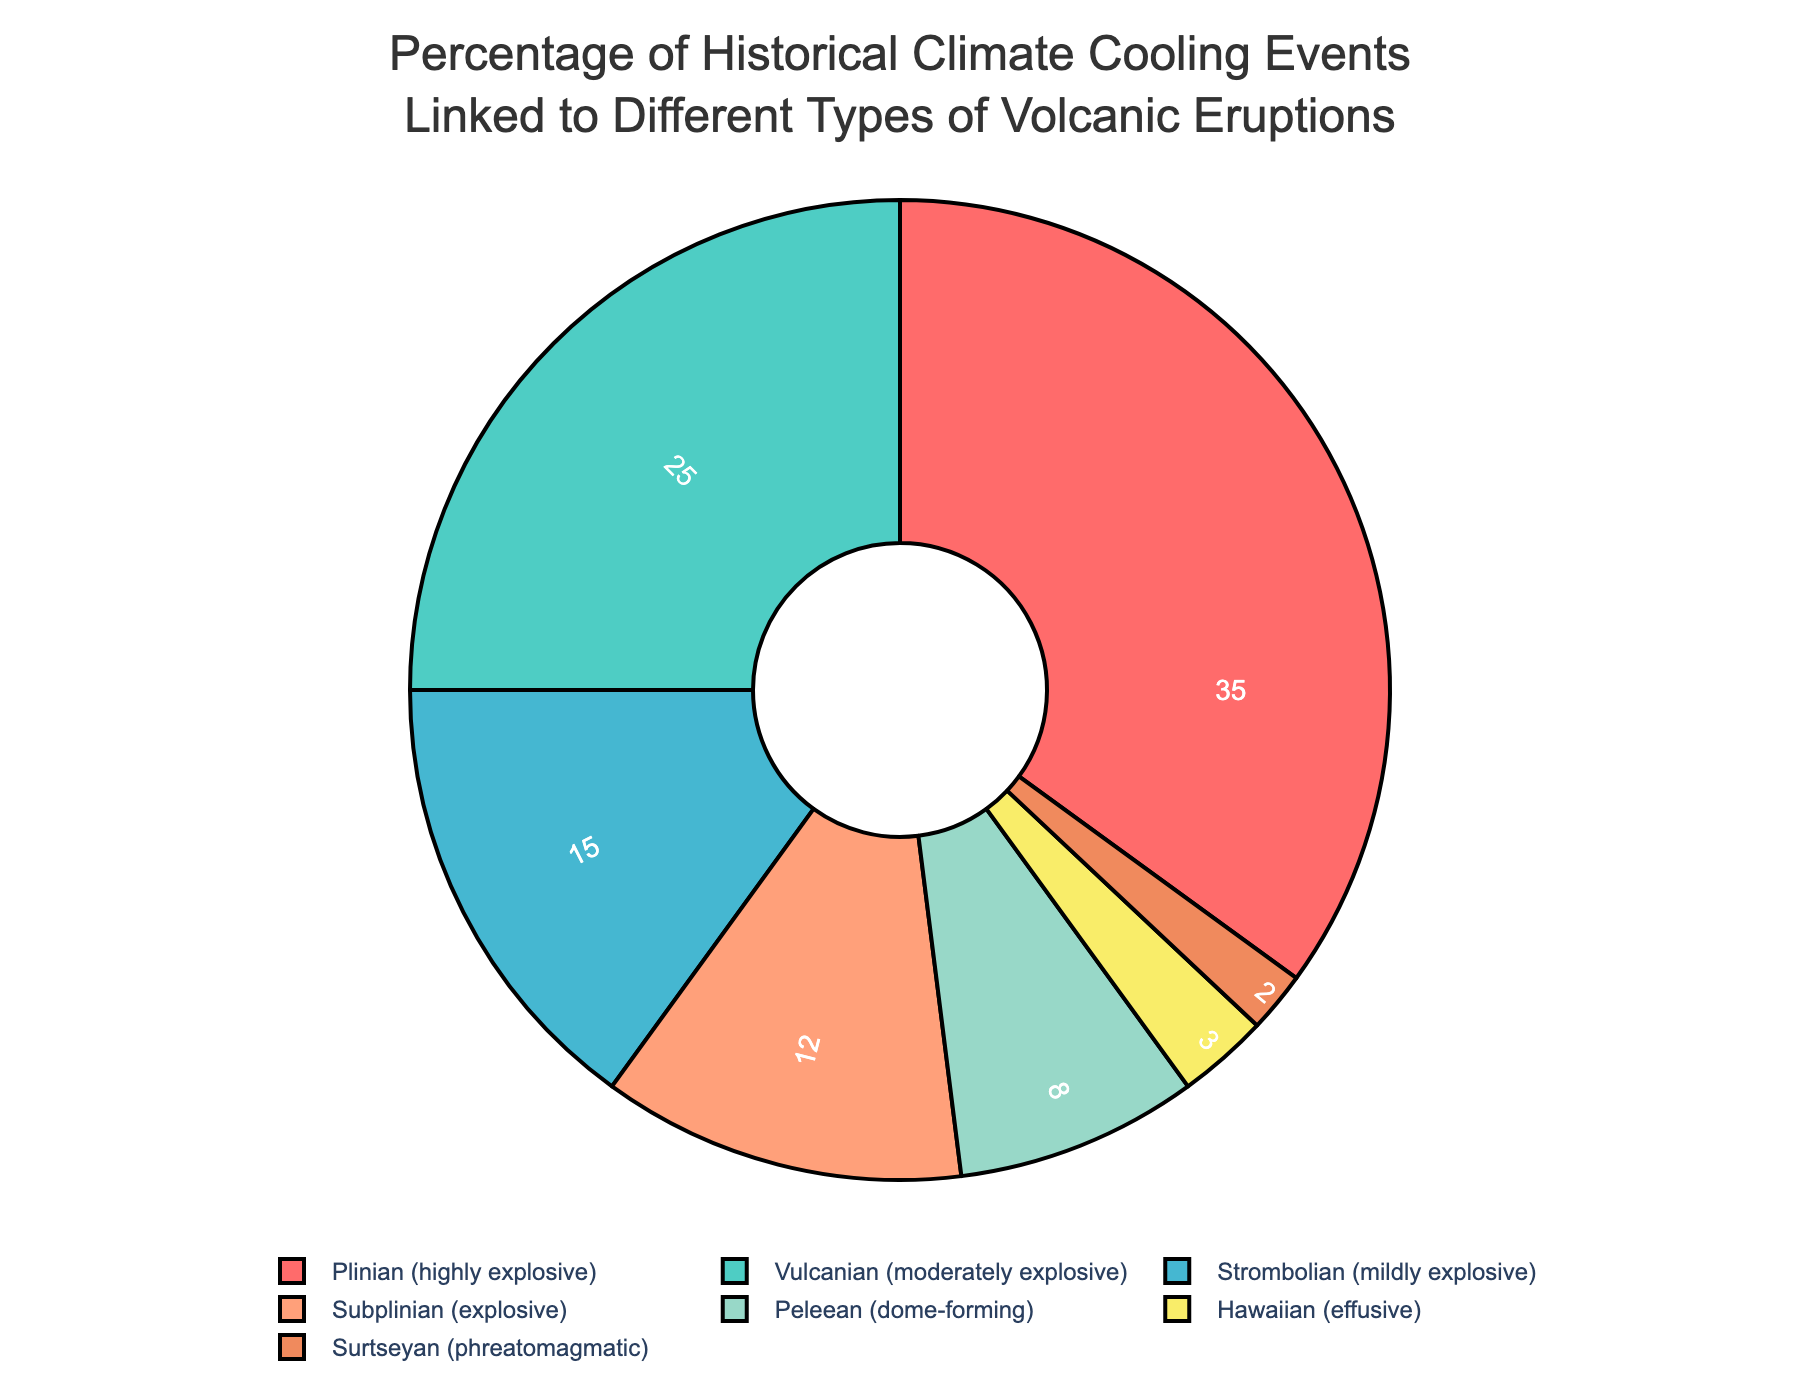What percentage of historical climate cooling events is linked to Plinian eruptions? The figure shows that the segment labeled "Plinian (highly explosive)" accounts for 35% of the climate cooling events.
Answer: 35% Which type of volcanic eruption contributes the least to historical climate cooling events? The figure shows that the segment labeled "Surtseyan (phreatomagmatic)" has the smallest percentage, which is 2%.
Answer: Surtseyan (phreatomagmatic) Compare the percentage of climate cooling events linked to Vulcanian eruptions to those linked to Strombolian eruptions. The figure shows that the percentage for Vulcanian eruptions is 25%, while for Strombolian eruptions it is 15%. Vulcanian eruptions contribute a higher percentage.
Answer: Vulcanian eruptions contribute more What is the combined percentage of historical climate cooling events linked to Plinian and Subplinian eruptions? The figure shows that Plinian eruptions account for 35% and Subplinian eruptions account for 12%. Adding these gives 35% + 12% = 47%.
Answer: 47% Which types of volcanic eruptions collectively contribute to more than 50% of the historical climate cooling events? The figure shows that Plinian (35%) and Vulcanian (25%) eruptions together contribute 35% + 25% = 60%, which is more than 50%.
Answer: Plinian and Vulcanian Rank the types of volcanic eruptions from highest to lowest based on their contribution to historical climate cooling events. The percentages shown in the figure are: Plinian (35%), Vulcanian (25%), Strombolian (15%), Subplinian (12%), Peleean (8%), Hawaiian (3%), Surtseyan (2%). Arranged in descending order, they are: Plinian, Vulcanian, Strombolian, Subplinian, Peleean, Hawaiian, Surtseyan.
Answer: Plinian, Vulcanian, Strombolian, Subplinian, Peleean, Hawaiian, Surtseyan Is the total percentage of climate cooling events linked to all explosive eruptions (Plinian, Vulcanian, Strombolian, Subplinian) more than 80%? Adding the percentages for Plinian (35%), Vulcanian (25%), Strombolian (15%), and Subplinian (12%) gives a total of 35% + 25% + 15% + 12% = 87%, which is more than 80%.
Answer: Yes What is the sum of the percentages of moderately explosive and dome-forming eruptions? The percentage for Vulcanian (moderately explosive) is 25%, and Peleean (dome-forming) is 8%. Summing them gives 25% + 8% = 33%.
Answer: 33% Which type of eruption, Subplinian or Peleean, is responsible for a greater percentage of historical climate cooling events? The figure shows that Subplinian eruptions account for 12% and Peleean eruptions account for 8%. Subplinian eruptions have a higher percentage.
Answer: Subplinian What is the average percentage of climate cooling events linked to Strombolian, Subplinian, and Peleean eruptions? The figure shows the percentages for Strombolian (15%), Subplinian (12%), and Peleean (8%). Adding these gives 15% + 12% + 8% = 35%. The average is 35% / 3 = 11.67%.
Answer: 11.67% 